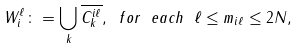<formula> <loc_0><loc_0><loc_500><loc_500>W _ { i } ^ { \ell } \colon = \bigcup _ { k } \overline { C ^ { i \ell } _ { k } } , \ f o r \ e a c h \ \ell \leq m _ { i \ell } \leq 2 N ,</formula> 